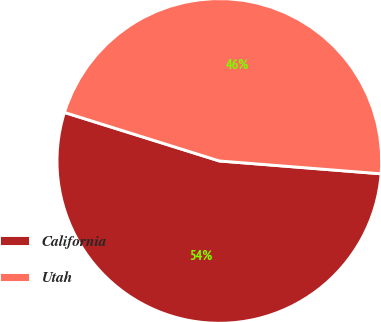Convert chart. <chart><loc_0><loc_0><loc_500><loc_500><pie_chart><fcel>California<fcel>Utah<nl><fcel>53.57%<fcel>46.43%<nl></chart> 